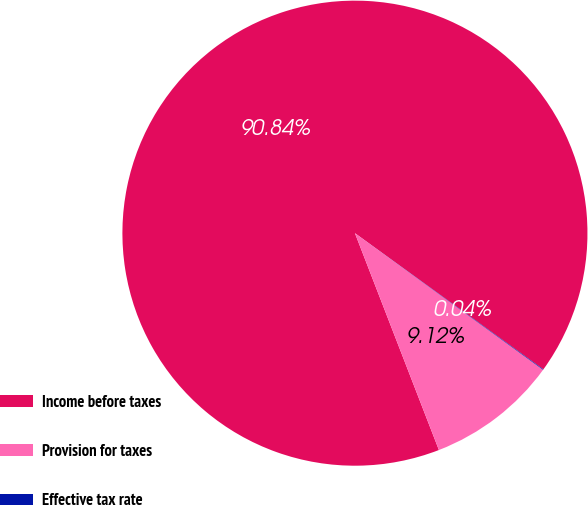<chart> <loc_0><loc_0><loc_500><loc_500><pie_chart><fcel>Income before taxes<fcel>Provision for taxes<fcel>Effective tax rate<nl><fcel>90.84%<fcel>9.12%<fcel>0.04%<nl></chart> 